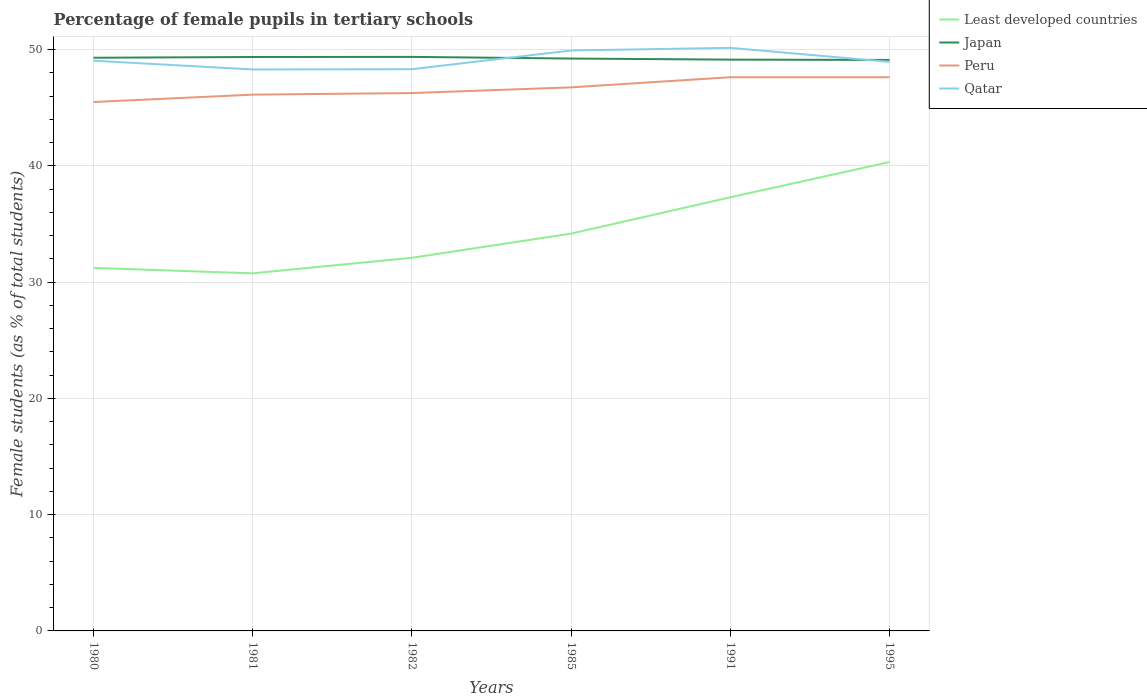How many different coloured lines are there?
Make the answer very short. 4. Does the line corresponding to Japan intersect with the line corresponding to Qatar?
Make the answer very short. Yes. Is the number of lines equal to the number of legend labels?
Your response must be concise. Yes. Across all years, what is the maximum percentage of female pupils in tertiary schools in Peru?
Offer a terse response. 45.5. In which year was the percentage of female pupils in tertiary schools in Qatar maximum?
Your answer should be very brief. 1981. What is the total percentage of female pupils in tertiary schools in Qatar in the graph?
Your response must be concise. -0.66. What is the difference between the highest and the second highest percentage of female pupils in tertiary schools in Least developed countries?
Your answer should be very brief. 9.57. How many years are there in the graph?
Your answer should be compact. 6. What is the difference between two consecutive major ticks on the Y-axis?
Your answer should be very brief. 10. Are the values on the major ticks of Y-axis written in scientific E-notation?
Make the answer very short. No. Does the graph contain any zero values?
Your answer should be compact. No. Does the graph contain grids?
Your response must be concise. Yes. Where does the legend appear in the graph?
Your answer should be very brief. Top right. How are the legend labels stacked?
Provide a short and direct response. Vertical. What is the title of the graph?
Your response must be concise. Percentage of female pupils in tertiary schools. What is the label or title of the X-axis?
Provide a short and direct response. Years. What is the label or title of the Y-axis?
Provide a succinct answer. Female students (as % of total students). What is the Female students (as % of total students) in Least developed countries in 1980?
Your answer should be very brief. 31.23. What is the Female students (as % of total students) in Japan in 1980?
Ensure brevity in your answer.  49.31. What is the Female students (as % of total students) in Peru in 1980?
Provide a succinct answer. 45.5. What is the Female students (as % of total students) of Qatar in 1980?
Ensure brevity in your answer.  49.05. What is the Female students (as % of total students) of Least developed countries in 1981?
Provide a short and direct response. 30.76. What is the Female students (as % of total students) in Japan in 1981?
Offer a very short reply. 49.37. What is the Female students (as % of total students) in Peru in 1981?
Your response must be concise. 46.13. What is the Female students (as % of total students) of Qatar in 1981?
Keep it short and to the point. 48.3. What is the Female students (as % of total students) of Least developed countries in 1982?
Provide a short and direct response. 32.1. What is the Female students (as % of total students) of Japan in 1982?
Provide a short and direct response. 49.38. What is the Female students (as % of total students) of Peru in 1982?
Keep it short and to the point. 46.27. What is the Female students (as % of total students) in Qatar in 1982?
Give a very brief answer. 48.32. What is the Female students (as % of total students) of Least developed countries in 1985?
Provide a short and direct response. 34.18. What is the Female students (as % of total students) in Japan in 1985?
Ensure brevity in your answer.  49.24. What is the Female students (as % of total students) of Peru in 1985?
Your answer should be compact. 46.76. What is the Female students (as % of total students) in Qatar in 1985?
Provide a short and direct response. 49.93. What is the Female students (as % of total students) of Least developed countries in 1991?
Your answer should be compact. 37.3. What is the Female students (as % of total students) in Japan in 1991?
Ensure brevity in your answer.  49.15. What is the Female students (as % of total students) in Peru in 1991?
Your answer should be very brief. 47.63. What is the Female students (as % of total students) in Qatar in 1991?
Give a very brief answer. 50.16. What is the Female students (as % of total students) in Least developed countries in 1995?
Keep it short and to the point. 40.33. What is the Female students (as % of total students) in Japan in 1995?
Make the answer very short. 49.12. What is the Female students (as % of total students) of Peru in 1995?
Give a very brief answer. 47.63. What is the Female students (as % of total students) in Qatar in 1995?
Give a very brief answer. 48.95. Across all years, what is the maximum Female students (as % of total students) in Least developed countries?
Offer a terse response. 40.33. Across all years, what is the maximum Female students (as % of total students) of Japan?
Provide a succinct answer. 49.38. Across all years, what is the maximum Female students (as % of total students) in Peru?
Offer a very short reply. 47.63. Across all years, what is the maximum Female students (as % of total students) in Qatar?
Keep it short and to the point. 50.16. Across all years, what is the minimum Female students (as % of total students) in Least developed countries?
Your answer should be very brief. 30.76. Across all years, what is the minimum Female students (as % of total students) in Japan?
Your response must be concise. 49.12. Across all years, what is the minimum Female students (as % of total students) in Peru?
Make the answer very short. 45.5. Across all years, what is the minimum Female students (as % of total students) in Qatar?
Provide a short and direct response. 48.3. What is the total Female students (as % of total students) in Least developed countries in the graph?
Your answer should be very brief. 205.91. What is the total Female students (as % of total students) in Japan in the graph?
Ensure brevity in your answer.  295.56. What is the total Female students (as % of total students) of Peru in the graph?
Ensure brevity in your answer.  279.92. What is the total Female students (as % of total students) of Qatar in the graph?
Make the answer very short. 294.72. What is the difference between the Female students (as % of total students) in Least developed countries in 1980 and that in 1981?
Your answer should be very brief. 0.47. What is the difference between the Female students (as % of total students) in Japan in 1980 and that in 1981?
Ensure brevity in your answer.  -0.06. What is the difference between the Female students (as % of total students) of Peru in 1980 and that in 1981?
Your answer should be compact. -0.63. What is the difference between the Female students (as % of total students) of Qatar in 1980 and that in 1981?
Offer a terse response. 0.75. What is the difference between the Female students (as % of total students) of Least developed countries in 1980 and that in 1982?
Your answer should be very brief. -0.87. What is the difference between the Female students (as % of total students) of Japan in 1980 and that in 1982?
Your response must be concise. -0.07. What is the difference between the Female students (as % of total students) of Peru in 1980 and that in 1982?
Make the answer very short. -0.77. What is the difference between the Female students (as % of total students) in Qatar in 1980 and that in 1982?
Give a very brief answer. 0.73. What is the difference between the Female students (as % of total students) in Least developed countries in 1980 and that in 1985?
Provide a short and direct response. -2.95. What is the difference between the Female students (as % of total students) of Japan in 1980 and that in 1985?
Your answer should be very brief. 0.07. What is the difference between the Female students (as % of total students) of Peru in 1980 and that in 1985?
Provide a succinct answer. -1.26. What is the difference between the Female students (as % of total students) of Qatar in 1980 and that in 1985?
Offer a very short reply. -0.88. What is the difference between the Female students (as % of total students) in Least developed countries in 1980 and that in 1991?
Your answer should be very brief. -6.08. What is the difference between the Female students (as % of total students) of Japan in 1980 and that in 1991?
Give a very brief answer. 0.16. What is the difference between the Female students (as % of total students) of Peru in 1980 and that in 1991?
Your answer should be compact. -2.13. What is the difference between the Female students (as % of total students) of Qatar in 1980 and that in 1991?
Provide a succinct answer. -1.11. What is the difference between the Female students (as % of total students) in Least developed countries in 1980 and that in 1995?
Offer a terse response. -9.11. What is the difference between the Female students (as % of total students) in Japan in 1980 and that in 1995?
Ensure brevity in your answer.  0.19. What is the difference between the Female students (as % of total students) of Peru in 1980 and that in 1995?
Provide a short and direct response. -2.13. What is the difference between the Female students (as % of total students) of Qatar in 1980 and that in 1995?
Give a very brief answer. 0.1. What is the difference between the Female students (as % of total students) in Least developed countries in 1981 and that in 1982?
Your answer should be compact. -1.34. What is the difference between the Female students (as % of total students) of Japan in 1981 and that in 1982?
Offer a terse response. -0.01. What is the difference between the Female students (as % of total students) in Peru in 1981 and that in 1982?
Ensure brevity in your answer.  -0.14. What is the difference between the Female students (as % of total students) in Qatar in 1981 and that in 1982?
Your answer should be compact. -0.02. What is the difference between the Female students (as % of total students) of Least developed countries in 1981 and that in 1985?
Give a very brief answer. -3.42. What is the difference between the Female students (as % of total students) of Japan in 1981 and that in 1985?
Keep it short and to the point. 0.13. What is the difference between the Female students (as % of total students) in Peru in 1981 and that in 1985?
Give a very brief answer. -0.63. What is the difference between the Female students (as % of total students) of Qatar in 1981 and that in 1985?
Your answer should be very brief. -1.63. What is the difference between the Female students (as % of total students) in Least developed countries in 1981 and that in 1991?
Your answer should be compact. -6.54. What is the difference between the Female students (as % of total students) of Japan in 1981 and that in 1991?
Give a very brief answer. 0.22. What is the difference between the Female students (as % of total students) in Peru in 1981 and that in 1991?
Your answer should be very brief. -1.5. What is the difference between the Female students (as % of total students) of Qatar in 1981 and that in 1991?
Offer a very short reply. -1.86. What is the difference between the Female students (as % of total students) of Least developed countries in 1981 and that in 1995?
Offer a very short reply. -9.57. What is the difference between the Female students (as % of total students) in Japan in 1981 and that in 1995?
Your answer should be compact. 0.25. What is the difference between the Female students (as % of total students) in Peru in 1981 and that in 1995?
Make the answer very short. -1.5. What is the difference between the Female students (as % of total students) of Qatar in 1981 and that in 1995?
Make the answer very short. -0.66. What is the difference between the Female students (as % of total students) of Least developed countries in 1982 and that in 1985?
Provide a succinct answer. -2.08. What is the difference between the Female students (as % of total students) of Japan in 1982 and that in 1985?
Provide a short and direct response. 0.14. What is the difference between the Female students (as % of total students) in Peru in 1982 and that in 1985?
Your answer should be compact. -0.49. What is the difference between the Female students (as % of total students) in Qatar in 1982 and that in 1985?
Keep it short and to the point. -1.61. What is the difference between the Female students (as % of total students) in Least developed countries in 1982 and that in 1991?
Provide a short and direct response. -5.2. What is the difference between the Female students (as % of total students) of Japan in 1982 and that in 1991?
Your answer should be very brief. 0.24. What is the difference between the Female students (as % of total students) in Peru in 1982 and that in 1991?
Your answer should be compact. -1.36. What is the difference between the Female students (as % of total students) in Qatar in 1982 and that in 1991?
Offer a very short reply. -1.84. What is the difference between the Female students (as % of total students) of Least developed countries in 1982 and that in 1995?
Keep it short and to the point. -8.23. What is the difference between the Female students (as % of total students) in Japan in 1982 and that in 1995?
Ensure brevity in your answer.  0.26. What is the difference between the Female students (as % of total students) in Peru in 1982 and that in 1995?
Keep it short and to the point. -1.36. What is the difference between the Female students (as % of total students) of Qatar in 1982 and that in 1995?
Your answer should be very brief. -0.63. What is the difference between the Female students (as % of total students) of Least developed countries in 1985 and that in 1991?
Make the answer very short. -3.12. What is the difference between the Female students (as % of total students) of Japan in 1985 and that in 1991?
Give a very brief answer. 0.09. What is the difference between the Female students (as % of total students) of Peru in 1985 and that in 1991?
Provide a succinct answer. -0.87. What is the difference between the Female students (as % of total students) of Qatar in 1985 and that in 1991?
Provide a succinct answer. -0.23. What is the difference between the Female students (as % of total students) in Least developed countries in 1985 and that in 1995?
Your response must be concise. -6.16. What is the difference between the Female students (as % of total students) of Japan in 1985 and that in 1995?
Your answer should be very brief. 0.12. What is the difference between the Female students (as % of total students) in Peru in 1985 and that in 1995?
Provide a short and direct response. -0.87. What is the difference between the Female students (as % of total students) in Qatar in 1985 and that in 1995?
Your answer should be very brief. 0.98. What is the difference between the Female students (as % of total students) of Least developed countries in 1991 and that in 1995?
Offer a very short reply. -3.03. What is the difference between the Female students (as % of total students) in Japan in 1991 and that in 1995?
Provide a short and direct response. 0.03. What is the difference between the Female students (as % of total students) of Peru in 1991 and that in 1995?
Your response must be concise. -0. What is the difference between the Female students (as % of total students) of Qatar in 1991 and that in 1995?
Give a very brief answer. 1.2. What is the difference between the Female students (as % of total students) in Least developed countries in 1980 and the Female students (as % of total students) in Japan in 1981?
Your answer should be compact. -18.14. What is the difference between the Female students (as % of total students) in Least developed countries in 1980 and the Female students (as % of total students) in Peru in 1981?
Your answer should be very brief. -14.9. What is the difference between the Female students (as % of total students) of Least developed countries in 1980 and the Female students (as % of total students) of Qatar in 1981?
Your answer should be very brief. -17.07. What is the difference between the Female students (as % of total students) in Japan in 1980 and the Female students (as % of total students) in Peru in 1981?
Your answer should be very brief. 3.17. What is the difference between the Female students (as % of total students) in Japan in 1980 and the Female students (as % of total students) in Qatar in 1981?
Offer a terse response. 1.01. What is the difference between the Female students (as % of total students) in Peru in 1980 and the Female students (as % of total students) in Qatar in 1981?
Your answer should be very brief. -2.8. What is the difference between the Female students (as % of total students) in Least developed countries in 1980 and the Female students (as % of total students) in Japan in 1982?
Keep it short and to the point. -18.15. What is the difference between the Female students (as % of total students) of Least developed countries in 1980 and the Female students (as % of total students) of Peru in 1982?
Your answer should be very brief. -15.04. What is the difference between the Female students (as % of total students) of Least developed countries in 1980 and the Female students (as % of total students) of Qatar in 1982?
Offer a terse response. -17.09. What is the difference between the Female students (as % of total students) in Japan in 1980 and the Female students (as % of total students) in Peru in 1982?
Provide a short and direct response. 3.04. What is the difference between the Female students (as % of total students) in Japan in 1980 and the Female students (as % of total students) in Qatar in 1982?
Give a very brief answer. 0.99. What is the difference between the Female students (as % of total students) of Peru in 1980 and the Female students (as % of total students) of Qatar in 1982?
Keep it short and to the point. -2.82. What is the difference between the Female students (as % of total students) in Least developed countries in 1980 and the Female students (as % of total students) in Japan in 1985?
Your answer should be compact. -18.01. What is the difference between the Female students (as % of total students) in Least developed countries in 1980 and the Female students (as % of total students) in Peru in 1985?
Make the answer very short. -15.53. What is the difference between the Female students (as % of total students) in Least developed countries in 1980 and the Female students (as % of total students) in Qatar in 1985?
Offer a very short reply. -18.7. What is the difference between the Female students (as % of total students) in Japan in 1980 and the Female students (as % of total students) in Peru in 1985?
Give a very brief answer. 2.55. What is the difference between the Female students (as % of total students) of Japan in 1980 and the Female students (as % of total students) of Qatar in 1985?
Your answer should be compact. -0.62. What is the difference between the Female students (as % of total students) of Peru in 1980 and the Female students (as % of total students) of Qatar in 1985?
Provide a succinct answer. -4.43. What is the difference between the Female students (as % of total students) in Least developed countries in 1980 and the Female students (as % of total students) in Japan in 1991?
Your response must be concise. -17.92. What is the difference between the Female students (as % of total students) in Least developed countries in 1980 and the Female students (as % of total students) in Peru in 1991?
Provide a succinct answer. -16.4. What is the difference between the Female students (as % of total students) of Least developed countries in 1980 and the Female students (as % of total students) of Qatar in 1991?
Your answer should be very brief. -18.93. What is the difference between the Female students (as % of total students) in Japan in 1980 and the Female students (as % of total students) in Peru in 1991?
Your answer should be very brief. 1.68. What is the difference between the Female students (as % of total students) in Japan in 1980 and the Female students (as % of total students) in Qatar in 1991?
Offer a very short reply. -0.85. What is the difference between the Female students (as % of total students) of Peru in 1980 and the Female students (as % of total students) of Qatar in 1991?
Provide a short and direct response. -4.66. What is the difference between the Female students (as % of total students) of Least developed countries in 1980 and the Female students (as % of total students) of Japan in 1995?
Your answer should be very brief. -17.89. What is the difference between the Female students (as % of total students) of Least developed countries in 1980 and the Female students (as % of total students) of Peru in 1995?
Your answer should be very brief. -16.4. What is the difference between the Female students (as % of total students) of Least developed countries in 1980 and the Female students (as % of total students) of Qatar in 1995?
Your response must be concise. -17.73. What is the difference between the Female students (as % of total students) of Japan in 1980 and the Female students (as % of total students) of Peru in 1995?
Offer a very short reply. 1.68. What is the difference between the Female students (as % of total students) in Japan in 1980 and the Female students (as % of total students) in Qatar in 1995?
Your response must be concise. 0.35. What is the difference between the Female students (as % of total students) of Peru in 1980 and the Female students (as % of total students) of Qatar in 1995?
Give a very brief answer. -3.46. What is the difference between the Female students (as % of total students) of Least developed countries in 1981 and the Female students (as % of total students) of Japan in 1982?
Your answer should be very brief. -18.62. What is the difference between the Female students (as % of total students) of Least developed countries in 1981 and the Female students (as % of total students) of Peru in 1982?
Give a very brief answer. -15.51. What is the difference between the Female students (as % of total students) in Least developed countries in 1981 and the Female students (as % of total students) in Qatar in 1982?
Offer a very short reply. -17.56. What is the difference between the Female students (as % of total students) in Japan in 1981 and the Female students (as % of total students) in Peru in 1982?
Provide a short and direct response. 3.1. What is the difference between the Female students (as % of total students) in Japan in 1981 and the Female students (as % of total students) in Qatar in 1982?
Ensure brevity in your answer.  1.05. What is the difference between the Female students (as % of total students) of Peru in 1981 and the Female students (as % of total students) of Qatar in 1982?
Your response must be concise. -2.19. What is the difference between the Female students (as % of total students) of Least developed countries in 1981 and the Female students (as % of total students) of Japan in 1985?
Ensure brevity in your answer.  -18.48. What is the difference between the Female students (as % of total students) in Least developed countries in 1981 and the Female students (as % of total students) in Peru in 1985?
Your answer should be compact. -16. What is the difference between the Female students (as % of total students) in Least developed countries in 1981 and the Female students (as % of total students) in Qatar in 1985?
Keep it short and to the point. -19.17. What is the difference between the Female students (as % of total students) in Japan in 1981 and the Female students (as % of total students) in Peru in 1985?
Provide a succinct answer. 2.61. What is the difference between the Female students (as % of total students) of Japan in 1981 and the Female students (as % of total students) of Qatar in 1985?
Offer a very short reply. -0.56. What is the difference between the Female students (as % of total students) of Peru in 1981 and the Female students (as % of total students) of Qatar in 1985?
Give a very brief answer. -3.8. What is the difference between the Female students (as % of total students) in Least developed countries in 1981 and the Female students (as % of total students) in Japan in 1991?
Make the answer very short. -18.38. What is the difference between the Female students (as % of total students) in Least developed countries in 1981 and the Female students (as % of total students) in Peru in 1991?
Ensure brevity in your answer.  -16.87. What is the difference between the Female students (as % of total students) of Least developed countries in 1981 and the Female students (as % of total students) of Qatar in 1991?
Provide a short and direct response. -19.4. What is the difference between the Female students (as % of total students) of Japan in 1981 and the Female students (as % of total students) of Peru in 1991?
Provide a short and direct response. 1.74. What is the difference between the Female students (as % of total students) of Japan in 1981 and the Female students (as % of total students) of Qatar in 1991?
Your answer should be compact. -0.79. What is the difference between the Female students (as % of total students) in Peru in 1981 and the Female students (as % of total students) in Qatar in 1991?
Provide a short and direct response. -4.03. What is the difference between the Female students (as % of total students) of Least developed countries in 1981 and the Female students (as % of total students) of Japan in 1995?
Your answer should be compact. -18.36. What is the difference between the Female students (as % of total students) of Least developed countries in 1981 and the Female students (as % of total students) of Peru in 1995?
Give a very brief answer. -16.87. What is the difference between the Female students (as % of total students) of Least developed countries in 1981 and the Female students (as % of total students) of Qatar in 1995?
Give a very brief answer. -18.19. What is the difference between the Female students (as % of total students) in Japan in 1981 and the Female students (as % of total students) in Peru in 1995?
Provide a succinct answer. 1.74. What is the difference between the Female students (as % of total students) in Japan in 1981 and the Female students (as % of total students) in Qatar in 1995?
Provide a succinct answer. 0.42. What is the difference between the Female students (as % of total students) of Peru in 1981 and the Female students (as % of total students) of Qatar in 1995?
Your answer should be very brief. -2.82. What is the difference between the Female students (as % of total students) of Least developed countries in 1982 and the Female students (as % of total students) of Japan in 1985?
Provide a short and direct response. -17.14. What is the difference between the Female students (as % of total students) in Least developed countries in 1982 and the Female students (as % of total students) in Peru in 1985?
Your answer should be compact. -14.66. What is the difference between the Female students (as % of total students) in Least developed countries in 1982 and the Female students (as % of total students) in Qatar in 1985?
Offer a terse response. -17.83. What is the difference between the Female students (as % of total students) in Japan in 1982 and the Female students (as % of total students) in Peru in 1985?
Offer a very short reply. 2.62. What is the difference between the Female students (as % of total students) of Japan in 1982 and the Female students (as % of total students) of Qatar in 1985?
Provide a succinct answer. -0.55. What is the difference between the Female students (as % of total students) of Peru in 1982 and the Female students (as % of total students) of Qatar in 1985?
Ensure brevity in your answer.  -3.66. What is the difference between the Female students (as % of total students) of Least developed countries in 1982 and the Female students (as % of total students) of Japan in 1991?
Give a very brief answer. -17.04. What is the difference between the Female students (as % of total students) of Least developed countries in 1982 and the Female students (as % of total students) of Peru in 1991?
Ensure brevity in your answer.  -15.53. What is the difference between the Female students (as % of total students) of Least developed countries in 1982 and the Female students (as % of total students) of Qatar in 1991?
Your answer should be compact. -18.06. What is the difference between the Female students (as % of total students) of Japan in 1982 and the Female students (as % of total students) of Peru in 1991?
Keep it short and to the point. 1.75. What is the difference between the Female students (as % of total students) in Japan in 1982 and the Female students (as % of total students) in Qatar in 1991?
Your answer should be compact. -0.78. What is the difference between the Female students (as % of total students) of Peru in 1982 and the Female students (as % of total students) of Qatar in 1991?
Your answer should be very brief. -3.89. What is the difference between the Female students (as % of total students) in Least developed countries in 1982 and the Female students (as % of total students) in Japan in 1995?
Offer a terse response. -17.02. What is the difference between the Female students (as % of total students) of Least developed countries in 1982 and the Female students (as % of total students) of Peru in 1995?
Ensure brevity in your answer.  -15.53. What is the difference between the Female students (as % of total students) of Least developed countries in 1982 and the Female students (as % of total students) of Qatar in 1995?
Ensure brevity in your answer.  -16.85. What is the difference between the Female students (as % of total students) in Japan in 1982 and the Female students (as % of total students) in Peru in 1995?
Make the answer very short. 1.75. What is the difference between the Female students (as % of total students) of Japan in 1982 and the Female students (as % of total students) of Qatar in 1995?
Give a very brief answer. 0.43. What is the difference between the Female students (as % of total students) of Peru in 1982 and the Female students (as % of total students) of Qatar in 1995?
Provide a succinct answer. -2.68. What is the difference between the Female students (as % of total students) of Least developed countries in 1985 and the Female students (as % of total students) of Japan in 1991?
Provide a short and direct response. -14.97. What is the difference between the Female students (as % of total students) of Least developed countries in 1985 and the Female students (as % of total students) of Peru in 1991?
Offer a terse response. -13.45. What is the difference between the Female students (as % of total students) of Least developed countries in 1985 and the Female students (as % of total students) of Qatar in 1991?
Provide a short and direct response. -15.98. What is the difference between the Female students (as % of total students) of Japan in 1985 and the Female students (as % of total students) of Peru in 1991?
Make the answer very short. 1.61. What is the difference between the Female students (as % of total students) of Japan in 1985 and the Female students (as % of total students) of Qatar in 1991?
Your answer should be very brief. -0.92. What is the difference between the Female students (as % of total students) in Peru in 1985 and the Female students (as % of total students) in Qatar in 1991?
Make the answer very short. -3.4. What is the difference between the Female students (as % of total students) in Least developed countries in 1985 and the Female students (as % of total students) in Japan in 1995?
Make the answer very short. -14.94. What is the difference between the Female students (as % of total students) of Least developed countries in 1985 and the Female students (as % of total students) of Peru in 1995?
Your answer should be very brief. -13.45. What is the difference between the Female students (as % of total students) of Least developed countries in 1985 and the Female students (as % of total students) of Qatar in 1995?
Your answer should be very brief. -14.78. What is the difference between the Female students (as % of total students) of Japan in 1985 and the Female students (as % of total students) of Peru in 1995?
Give a very brief answer. 1.61. What is the difference between the Female students (as % of total students) in Japan in 1985 and the Female students (as % of total students) in Qatar in 1995?
Provide a succinct answer. 0.28. What is the difference between the Female students (as % of total students) of Peru in 1985 and the Female students (as % of total students) of Qatar in 1995?
Your response must be concise. -2.19. What is the difference between the Female students (as % of total students) of Least developed countries in 1991 and the Female students (as % of total students) of Japan in 1995?
Provide a short and direct response. -11.82. What is the difference between the Female students (as % of total students) of Least developed countries in 1991 and the Female students (as % of total students) of Peru in 1995?
Keep it short and to the point. -10.33. What is the difference between the Female students (as % of total students) of Least developed countries in 1991 and the Female students (as % of total students) of Qatar in 1995?
Your answer should be very brief. -11.65. What is the difference between the Female students (as % of total students) of Japan in 1991 and the Female students (as % of total students) of Peru in 1995?
Your answer should be compact. 1.51. What is the difference between the Female students (as % of total students) in Japan in 1991 and the Female students (as % of total students) in Qatar in 1995?
Provide a succinct answer. 0.19. What is the difference between the Female students (as % of total students) of Peru in 1991 and the Female students (as % of total students) of Qatar in 1995?
Your answer should be compact. -1.32. What is the average Female students (as % of total students) of Least developed countries per year?
Keep it short and to the point. 34.32. What is the average Female students (as % of total students) of Japan per year?
Your answer should be compact. 49.26. What is the average Female students (as % of total students) of Peru per year?
Offer a terse response. 46.65. What is the average Female students (as % of total students) in Qatar per year?
Make the answer very short. 49.12. In the year 1980, what is the difference between the Female students (as % of total students) of Least developed countries and Female students (as % of total students) of Japan?
Your response must be concise. -18.08. In the year 1980, what is the difference between the Female students (as % of total students) of Least developed countries and Female students (as % of total students) of Peru?
Offer a very short reply. -14.27. In the year 1980, what is the difference between the Female students (as % of total students) in Least developed countries and Female students (as % of total students) in Qatar?
Make the answer very short. -17.83. In the year 1980, what is the difference between the Female students (as % of total students) in Japan and Female students (as % of total students) in Peru?
Ensure brevity in your answer.  3.81. In the year 1980, what is the difference between the Female students (as % of total students) of Japan and Female students (as % of total students) of Qatar?
Keep it short and to the point. 0.25. In the year 1980, what is the difference between the Female students (as % of total students) of Peru and Female students (as % of total students) of Qatar?
Provide a short and direct response. -3.56. In the year 1981, what is the difference between the Female students (as % of total students) of Least developed countries and Female students (as % of total students) of Japan?
Provide a succinct answer. -18.61. In the year 1981, what is the difference between the Female students (as % of total students) of Least developed countries and Female students (as % of total students) of Peru?
Ensure brevity in your answer.  -15.37. In the year 1981, what is the difference between the Female students (as % of total students) in Least developed countries and Female students (as % of total students) in Qatar?
Provide a succinct answer. -17.54. In the year 1981, what is the difference between the Female students (as % of total students) of Japan and Female students (as % of total students) of Peru?
Your answer should be compact. 3.24. In the year 1981, what is the difference between the Female students (as % of total students) in Japan and Female students (as % of total students) in Qatar?
Provide a short and direct response. 1.07. In the year 1981, what is the difference between the Female students (as % of total students) in Peru and Female students (as % of total students) in Qatar?
Make the answer very short. -2.17. In the year 1982, what is the difference between the Female students (as % of total students) in Least developed countries and Female students (as % of total students) in Japan?
Your response must be concise. -17.28. In the year 1982, what is the difference between the Female students (as % of total students) in Least developed countries and Female students (as % of total students) in Peru?
Your answer should be compact. -14.17. In the year 1982, what is the difference between the Female students (as % of total students) in Least developed countries and Female students (as % of total students) in Qatar?
Offer a very short reply. -16.22. In the year 1982, what is the difference between the Female students (as % of total students) of Japan and Female students (as % of total students) of Peru?
Offer a terse response. 3.11. In the year 1982, what is the difference between the Female students (as % of total students) of Japan and Female students (as % of total students) of Qatar?
Make the answer very short. 1.06. In the year 1982, what is the difference between the Female students (as % of total students) in Peru and Female students (as % of total students) in Qatar?
Your response must be concise. -2.05. In the year 1985, what is the difference between the Female students (as % of total students) in Least developed countries and Female students (as % of total students) in Japan?
Your answer should be compact. -15.06. In the year 1985, what is the difference between the Female students (as % of total students) of Least developed countries and Female students (as % of total students) of Peru?
Your answer should be very brief. -12.58. In the year 1985, what is the difference between the Female students (as % of total students) in Least developed countries and Female students (as % of total students) in Qatar?
Ensure brevity in your answer.  -15.75. In the year 1985, what is the difference between the Female students (as % of total students) of Japan and Female students (as % of total students) of Peru?
Offer a very short reply. 2.48. In the year 1985, what is the difference between the Female students (as % of total students) of Japan and Female students (as % of total students) of Qatar?
Offer a very short reply. -0.69. In the year 1985, what is the difference between the Female students (as % of total students) in Peru and Female students (as % of total students) in Qatar?
Offer a very short reply. -3.17. In the year 1991, what is the difference between the Female students (as % of total students) in Least developed countries and Female students (as % of total students) in Japan?
Offer a terse response. -11.84. In the year 1991, what is the difference between the Female students (as % of total students) in Least developed countries and Female students (as % of total students) in Peru?
Offer a very short reply. -10.33. In the year 1991, what is the difference between the Female students (as % of total students) of Least developed countries and Female students (as % of total students) of Qatar?
Your answer should be compact. -12.86. In the year 1991, what is the difference between the Female students (as % of total students) of Japan and Female students (as % of total students) of Peru?
Your answer should be very brief. 1.52. In the year 1991, what is the difference between the Female students (as % of total students) in Japan and Female students (as % of total students) in Qatar?
Your response must be concise. -1.01. In the year 1991, what is the difference between the Female students (as % of total students) of Peru and Female students (as % of total students) of Qatar?
Provide a succinct answer. -2.53. In the year 1995, what is the difference between the Female students (as % of total students) in Least developed countries and Female students (as % of total students) in Japan?
Offer a very short reply. -8.79. In the year 1995, what is the difference between the Female students (as % of total students) in Least developed countries and Female students (as % of total students) in Peru?
Make the answer very short. -7.3. In the year 1995, what is the difference between the Female students (as % of total students) in Least developed countries and Female students (as % of total students) in Qatar?
Your answer should be compact. -8.62. In the year 1995, what is the difference between the Female students (as % of total students) in Japan and Female students (as % of total students) in Peru?
Ensure brevity in your answer.  1.49. In the year 1995, what is the difference between the Female students (as % of total students) of Japan and Female students (as % of total students) of Qatar?
Offer a very short reply. 0.16. In the year 1995, what is the difference between the Female students (as % of total students) in Peru and Female students (as % of total students) in Qatar?
Give a very brief answer. -1.32. What is the ratio of the Female students (as % of total students) in Least developed countries in 1980 to that in 1981?
Provide a succinct answer. 1.02. What is the ratio of the Female students (as % of total students) in Japan in 1980 to that in 1981?
Make the answer very short. 1. What is the ratio of the Female students (as % of total students) in Peru in 1980 to that in 1981?
Your answer should be very brief. 0.99. What is the ratio of the Female students (as % of total students) of Qatar in 1980 to that in 1981?
Make the answer very short. 1.02. What is the ratio of the Female students (as % of total students) of Least developed countries in 1980 to that in 1982?
Make the answer very short. 0.97. What is the ratio of the Female students (as % of total students) of Peru in 1980 to that in 1982?
Your answer should be very brief. 0.98. What is the ratio of the Female students (as % of total students) in Qatar in 1980 to that in 1982?
Offer a very short reply. 1.02. What is the ratio of the Female students (as % of total students) in Least developed countries in 1980 to that in 1985?
Offer a terse response. 0.91. What is the ratio of the Female students (as % of total students) of Qatar in 1980 to that in 1985?
Offer a terse response. 0.98. What is the ratio of the Female students (as % of total students) in Least developed countries in 1980 to that in 1991?
Give a very brief answer. 0.84. What is the ratio of the Female students (as % of total students) in Japan in 1980 to that in 1991?
Offer a terse response. 1. What is the ratio of the Female students (as % of total students) of Peru in 1980 to that in 1991?
Provide a short and direct response. 0.96. What is the ratio of the Female students (as % of total students) in Least developed countries in 1980 to that in 1995?
Your response must be concise. 0.77. What is the ratio of the Female students (as % of total students) in Peru in 1980 to that in 1995?
Your answer should be very brief. 0.96. What is the ratio of the Female students (as % of total students) of Qatar in 1980 to that in 1995?
Offer a terse response. 1. What is the ratio of the Female students (as % of total students) in Least developed countries in 1981 to that in 1982?
Your answer should be very brief. 0.96. What is the ratio of the Female students (as % of total students) in Japan in 1981 to that in 1982?
Offer a very short reply. 1. What is the ratio of the Female students (as % of total students) of Peru in 1981 to that in 1985?
Your response must be concise. 0.99. What is the ratio of the Female students (as % of total students) of Qatar in 1981 to that in 1985?
Your answer should be compact. 0.97. What is the ratio of the Female students (as % of total students) of Least developed countries in 1981 to that in 1991?
Your answer should be very brief. 0.82. What is the ratio of the Female students (as % of total students) of Peru in 1981 to that in 1991?
Your answer should be very brief. 0.97. What is the ratio of the Female students (as % of total students) in Qatar in 1981 to that in 1991?
Offer a very short reply. 0.96. What is the ratio of the Female students (as % of total students) of Least developed countries in 1981 to that in 1995?
Ensure brevity in your answer.  0.76. What is the ratio of the Female students (as % of total students) of Japan in 1981 to that in 1995?
Provide a succinct answer. 1.01. What is the ratio of the Female students (as % of total students) of Peru in 1981 to that in 1995?
Your answer should be very brief. 0.97. What is the ratio of the Female students (as % of total students) of Qatar in 1981 to that in 1995?
Offer a very short reply. 0.99. What is the ratio of the Female students (as % of total students) of Least developed countries in 1982 to that in 1985?
Offer a terse response. 0.94. What is the ratio of the Female students (as % of total students) of Qatar in 1982 to that in 1985?
Your answer should be very brief. 0.97. What is the ratio of the Female students (as % of total students) in Least developed countries in 1982 to that in 1991?
Ensure brevity in your answer.  0.86. What is the ratio of the Female students (as % of total students) of Japan in 1982 to that in 1991?
Provide a succinct answer. 1. What is the ratio of the Female students (as % of total students) in Peru in 1982 to that in 1991?
Offer a terse response. 0.97. What is the ratio of the Female students (as % of total students) in Qatar in 1982 to that in 1991?
Your answer should be compact. 0.96. What is the ratio of the Female students (as % of total students) of Least developed countries in 1982 to that in 1995?
Your answer should be very brief. 0.8. What is the ratio of the Female students (as % of total students) of Japan in 1982 to that in 1995?
Ensure brevity in your answer.  1.01. What is the ratio of the Female students (as % of total students) of Peru in 1982 to that in 1995?
Your answer should be very brief. 0.97. What is the ratio of the Female students (as % of total students) of Qatar in 1982 to that in 1995?
Provide a succinct answer. 0.99. What is the ratio of the Female students (as % of total students) in Least developed countries in 1985 to that in 1991?
Provide a short and direct response. 0.92. What is the ratio of the Female students (as % of total students) of Japan in 1985 to that in 1991?
Keep it short and to the point. 1. What is the ratio of the Female students (as % of total students) of Peru in 1985 to that in 1991?
Your answer should be compact. 0.98. What is the ratio of the Female students (as % of total students) in Qatar in 1985 to that in 1991?
Keep it short and to the point. 1. What is the ratio of the Female students (as % of total students) in Least developed countries in 1985 to that in 1995?
Your response must be concise. 0.85. What is the ratio of the Female students (as % of total students) in Peru in 1985 to that in 1995?
Provide a succinct answer. 0.98. What is the ratio of the Female students (as % of total students) in Qatar in 1985 to that in 1995?
Keep it short and to the point. 1.02. What is the ratio of the Female students (as % of total students) in Least developed countries in 1991 to that in 1995?
Your answer should be compact. 0.92. What is the ratio of the Female students (as % of total students) of Japan in 1991 to that in 1995?
Keep it short and to the point. 1. What is the ratio of the Female students (as % of total students) of Qatar in 1991 to that in 1995?
Your response must be concise. 1.02. What is the difference between the highest and the second highest Female students (as % of total students) in Least developed countries?
Your answer should be very brief. 3.03. What is the difference between the highest and the second highest Female students (as % of total students) in Japan?
Your response must be concise. 0.01. What is the difference between the highest and the second highest Female students (as % of total students) in Peru?
Make the answer very short. 0. What is the difference between the highest and the second highest Female students (as % of total students) in Qatar?
Keep it short and to the point. 0.23. What is the difference between the highest and the lowest Female students (as % of total students) in Least developed countries?
Ensure brevity in your answer.  9.57. What is the difference between the highest and the lowest Female students (as % of total students) of Japan?
Give a very brief answer. 0.26. What is the difference between the highest and the lowest Female students (as % of total students) of Peru?
Your response must be concise. 2.13. What is the difference between the highest and the lowest Female students (as % of total students) in Qatar?
Give a very brief answer. 1.86. 